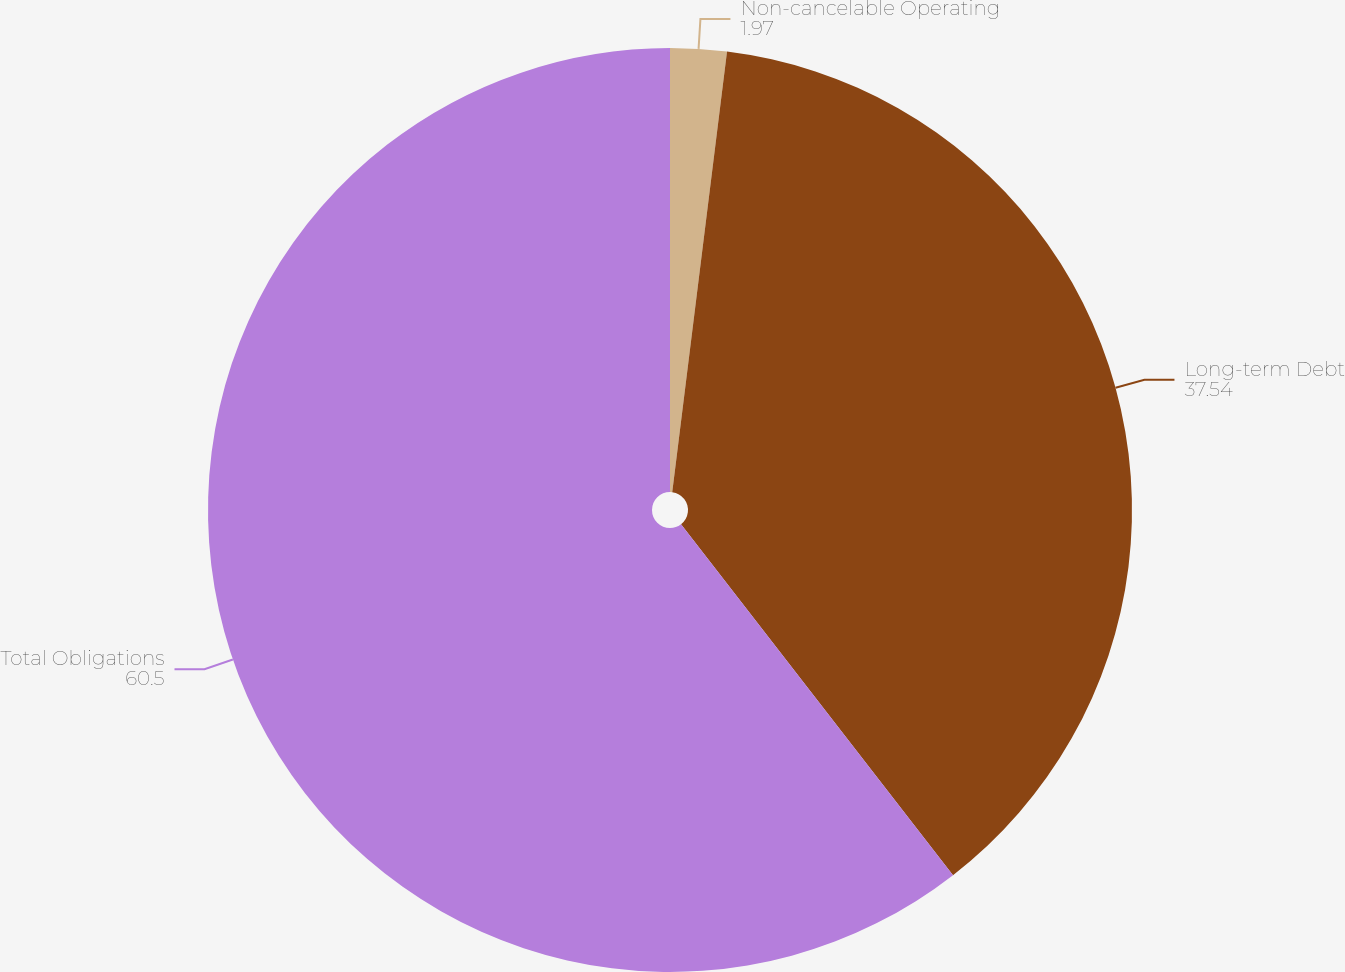<chart> <loc_0><loc_0><loc_500><loc_500><pie_chart><fcel>Non-cancelable Operating<fcel>Long-term Debt<fcel>Total Obligations<nl><fcel>1.97%<fcel>37.54%<fcel>60.5%<nl></chart> 